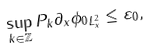<formula> <loc_0><loc_0><loc_500><loc_500>\sup _ { k \in \mathbb { Z } } \| P _ { k } \partial _ { x } \phi _ { 0 } \| _ { L ^ { 2 } _ { x } } \leq \varepsilon _ { 0 } ,</formula> 